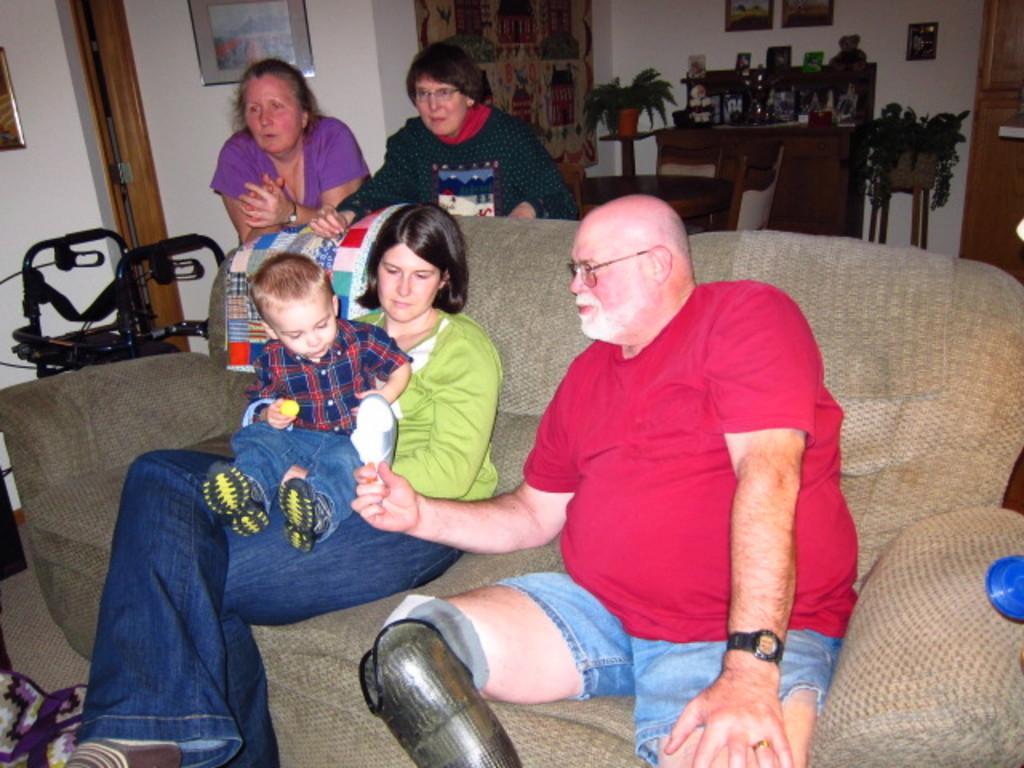Please provide a concise description of this image. These two persons are standing,these two persons are sitting on the sofa and this person holding a baby with her hands. On the background we can see wall,frames,objects on the table. 